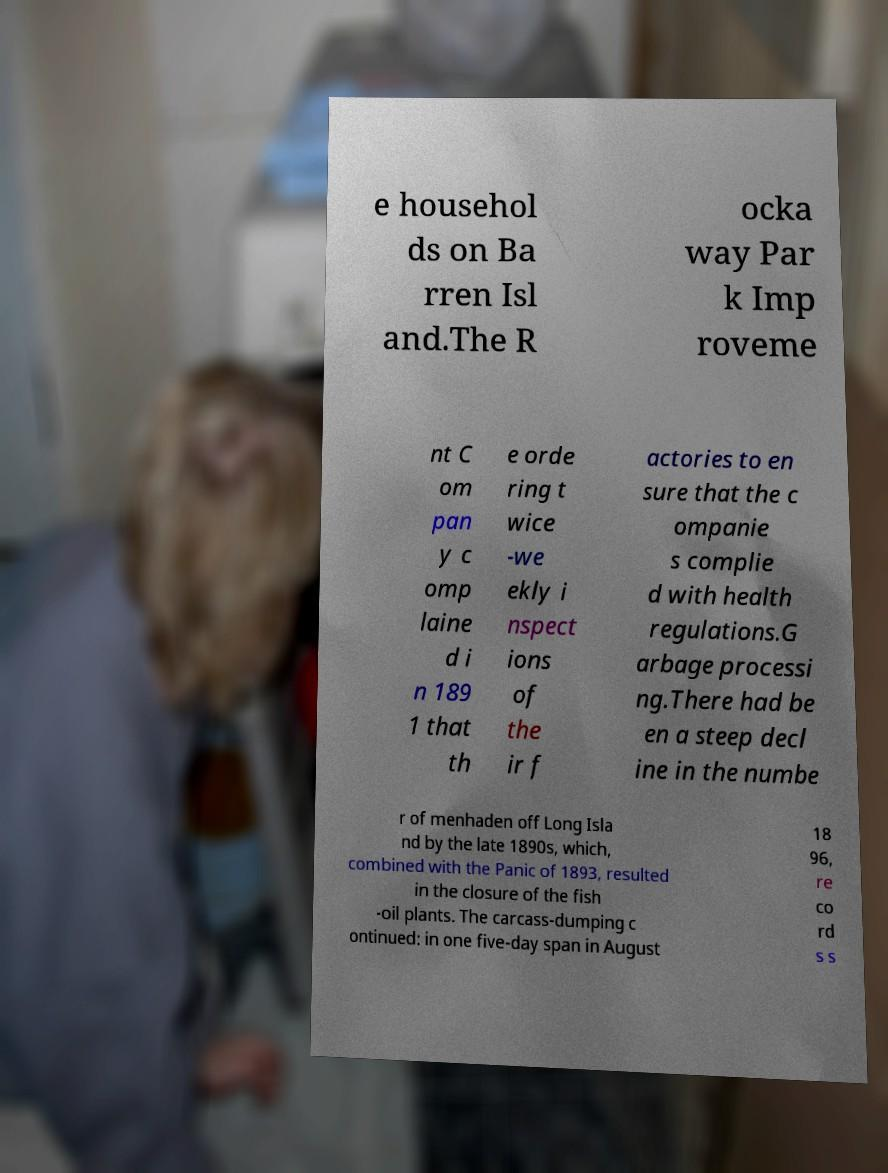For documentation purposes, I need the text within this image transcribed. Could you provide that? e househol ds on Ba rren Isl and.The R ocka way Par k Imp roveme nt C om pan y c omp laine d i n 189 1 that th e orde ring t wice -we ekly i nspect ions of the ir f actories to en sure that the c ompanie s complie d with health regulations.G arbage processi ng.There had be en a steep decl ine in the numbe r of menhaden off Long Isla nd by the late 1890s, which, combined with the Panic of 1893, resulted in the closure of the fish -oil plants. The carcass-dumping c ontinued: in one five-day span in August 18 96, re co rd s s 